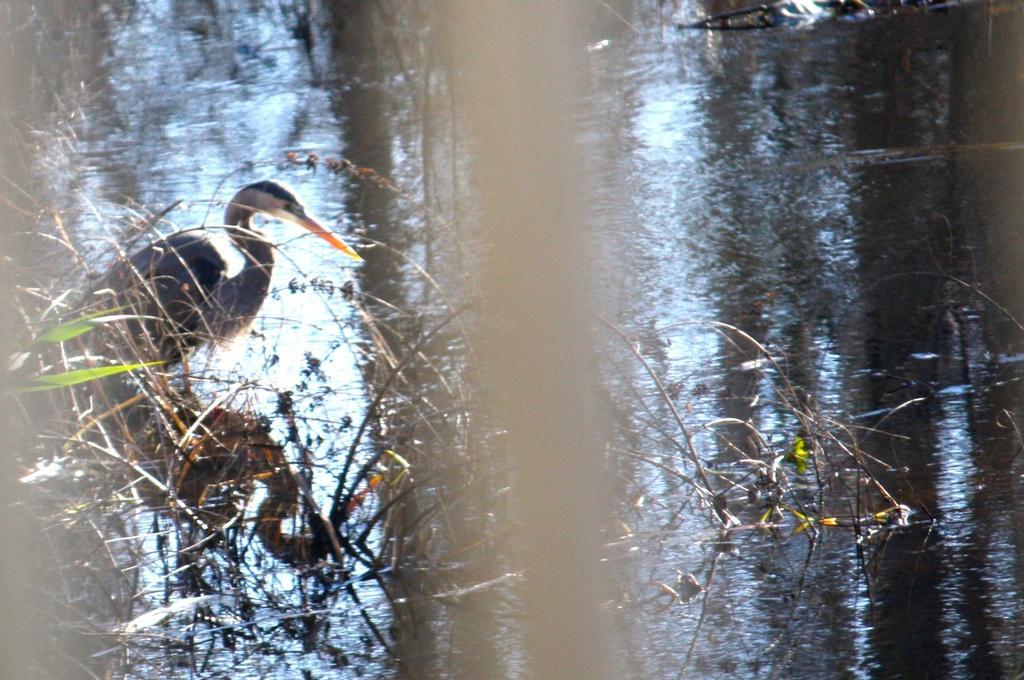Please provide a concise description of this image. In this image I see a bird over here which is of white and black in color and I see the water and I see few plants. 